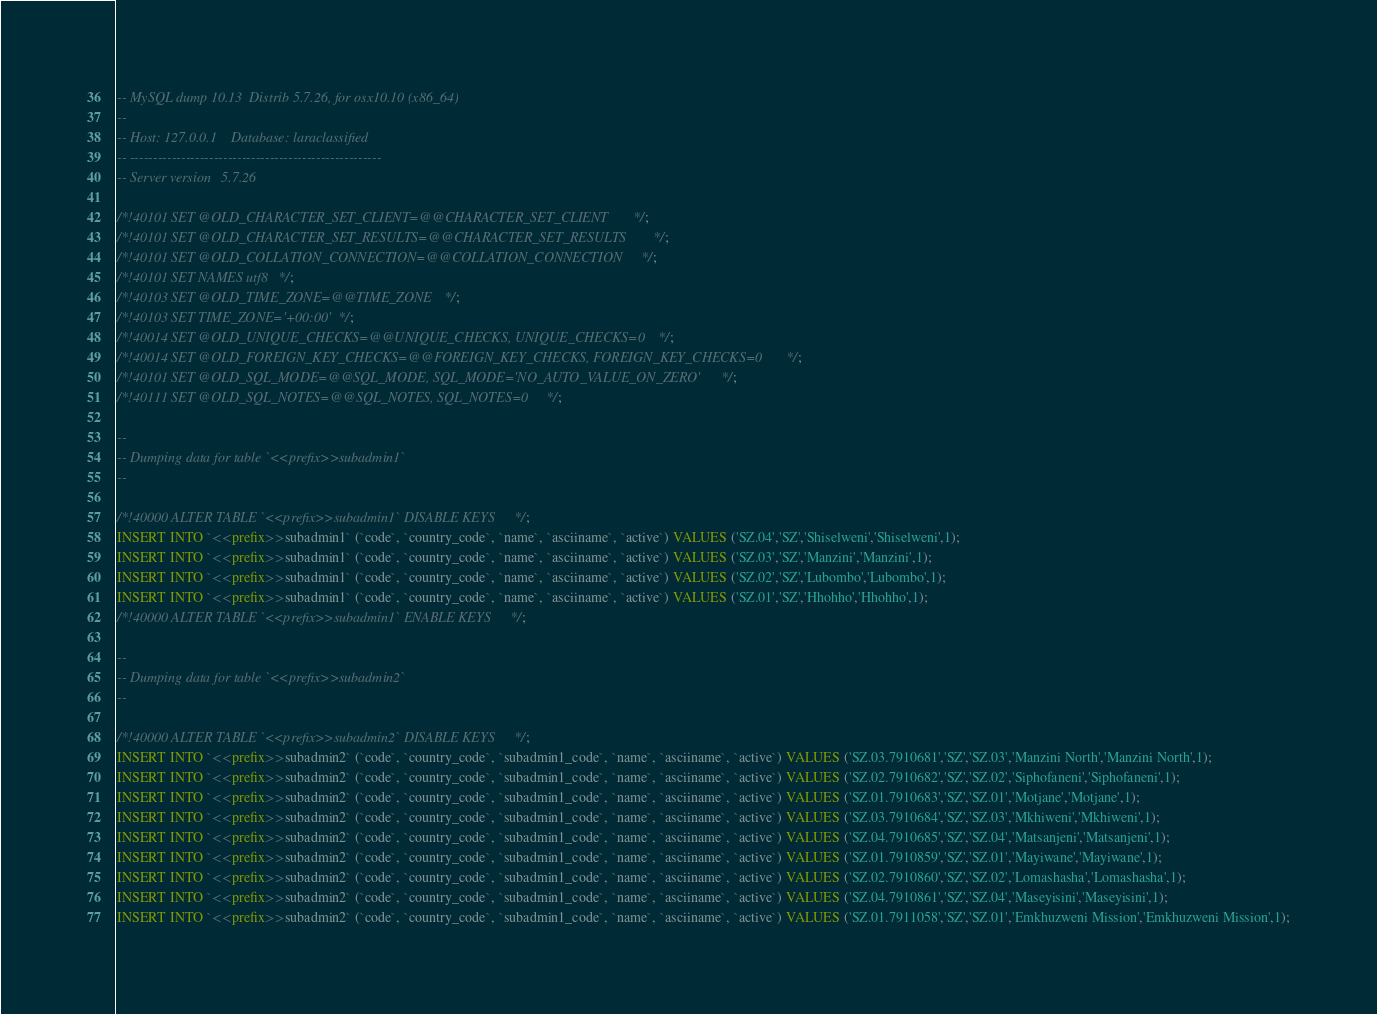Convert code to text. <code><loc_0><loc_0><loc_500><loc_500><_SQL_>-- MySQL dump 10.13  Distrib 5.7.26, for osx10.10 (x86_64)
--
-- Host: 127.0.0.1    Database: laraclassified
-- ------------------------------------------------------
-- Server version	5.7.26

/*!40101 SET @OLD_CHARACTER_SET_CLIENT=@@CHARACTER_SET_CLIENT */;
/*!40101 SET @OLD_CHARACTER_SET_RESULTS=@@CHARACTER_SET_RESULTS */;
/*!40101 SET @OLD_COLLATION_CONNECTION=@@COLLATION_CONNECTION */;
/*!40101 SET NAMES utf8 */;
/*!40103 SET @OLD_TIME_ZONE=@@TIME_ZONE */;
/*!40103 SET TIME_ZONE='+00:00' */;
/*!40014 SET @OLD_UNIQUE_CHECKS=@@UNIQUE_CHECKS, UNIQUE_CHECKS=0 */;
/*!40014 SET @OLD_FOREIGN_KEY_CHECKS=@@FOREIGN_KEY_CHECKS, FOREIGN_KEY_CHECKS=0 */;
/*!40101 SET @OLD_SQL_MODE=@@SQL_MODE, SQL_MODE='NO_AUTO_VALUE_ON_ZERO' */;
/*!40111 SET @OLD_SQL_NOTES=@@SQL_NOTES, SQL_NOTES=0 */;

--
-- Dumping data for table `<<prefix>>subadmin1`
--

/*!40000 ALTER TABLE `<<prefix>>subadmin1` DISABLE KEYS */;
INSERT INTO `<<prefix>>subadmin1` (`code`, `country_code`, `name`, `asciiname`, `active`) VALUES ('SZ.04','SZ','Shiselweni','Shiselweni',1);
INSERT INTO `<<prefix>>subadmin1` (`code`, `country_code`, `name`, `asciiname`, `active`) VALUES ('SZ.03','SZ','Manzini','Manzini',1);
INSERT INTO `<<prefix>>subadmin1` (`code`, `country_code`, `name`, `asciiname`, `active`) VALUES ('SZ.02','SZ','Lubombo','Lubombo',1);
INSERT INTO `<<prefix>>subadmin1` (`code`, `country_code`, `name`, `asciiname`, `active`) VALUES ('SZ.01','SZ','Hhohho','Hhohho',1);
/*!40000 ALTER TABLE `<<prefix>>subadmin1` ENABLE KEYS */;

--
-- Dumping data for table `<<prefix>>subadmin2`
--

/*!40000 ALTER TABLE `<<prefix>>subadmin2` DISABLE KEYS */;
INSERT INTO `<<prefix>>subadmin2` (`code`, `country_code`, `subadmin1_code`, `name`, `asciiname`, `active`) VALUES ('SZ.03.7910681','SZ','SZ.03','Manzini North','Manzini North',1);
INSERT INTO `<<prefix>>subadmin2` (`code`, `country_code`, `subadmin1_code`, `name`, `asciiname`, `active`) VALUES ('SZ.02.7910682','SZ','SZ.02','Siphofaneni','Siphofaneni',1);
INSERT INTO `<<prefix>>subadmin2` (`code`, `country_code`, `subadmin1_code`, `name`, `asciiname`, `active`) VALUES ('SZ.01.7910683','SZ','SZ.01','Motjane','Motjane',1);
INSERT INTO `<<prefix>>subadmin2` (`code`, `country_code`, `subadmin1_code`, `name`, `asciiname`, `active`) VALUES ('SZ.03.7910684','SZ','SZ.03','Mkhiweni','Mkhiweni',1);
INSERT INTO `<<prefix>>subadmin2` (`code`, `country_code`, `subadmin1_code`, `name`, `asciiname`, `active`) VALUES ('SZ.04.7910685','SZ','SZ.04','Matsanjeni','Matsanjeni',1);
INSERT INTO `<<prefix>>subadmin2` (`code`, `country_code`, `subadmin1_code`, `name`, `asciiname`, `active`) VALUES ('SZ.01.7910859','SZ','SZ.01','Mayiwane','Mayiwane',1);
INSERT INTO `<<prefix>>subadmin2` (`code`, `country_code`, `subadmin1_code`, `name`, `asciiname`, `active`) VALUES ('SZ.02.7910860','SZ','SZ.02','Lomashasha','Lomashasha',1);
INSERT INTO `<<prefix>>subadmin2` (`code`, `country_code`, `subadmin1_code`, `name`, `asciiname`, `active`) VALUES ('SZ.04.7910861','SZ','SZ.04','Maseyisini','Maseyisini',1);
INSERT INTO `<<prefix>>subadmin2` (`code`, `country_code`, `subadmin1_code`, `name`, `asciiname`, `active`) VALUES ('SZ.01.7911058','SZ','SZ.01','Emkhuzweni Mission','Emkhuzweni Mission',1);</code> 